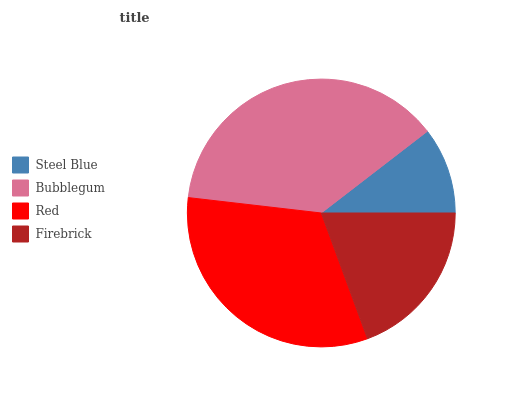Is Steel Blue the minimum?
Answer yes or no. Yes. Is Bubblegum the maximum?
Answer yes or no. Yes. Is Red the minimum?
Answer yes or no. No. Is Red the maximum?
Answer yes or no. No. Is Bubblegum greater than Red?
Answer yes or no. Yes. Is Red less than Bubblegum?
Answer yes or no. Yes. Is Red greater than Bubblegum?
Answer yes or no. No. Is Bubblegum less than Red?
Answer yes or no. No. Is Red the high median?
Answer yes or no. Yes. Is Firebrick the low median?
Answer yes or no. Yes. Is Bubblegum the high median?
Answer yes or no. No. Is Steel Blue the low median?
Answer yes or no. No. 